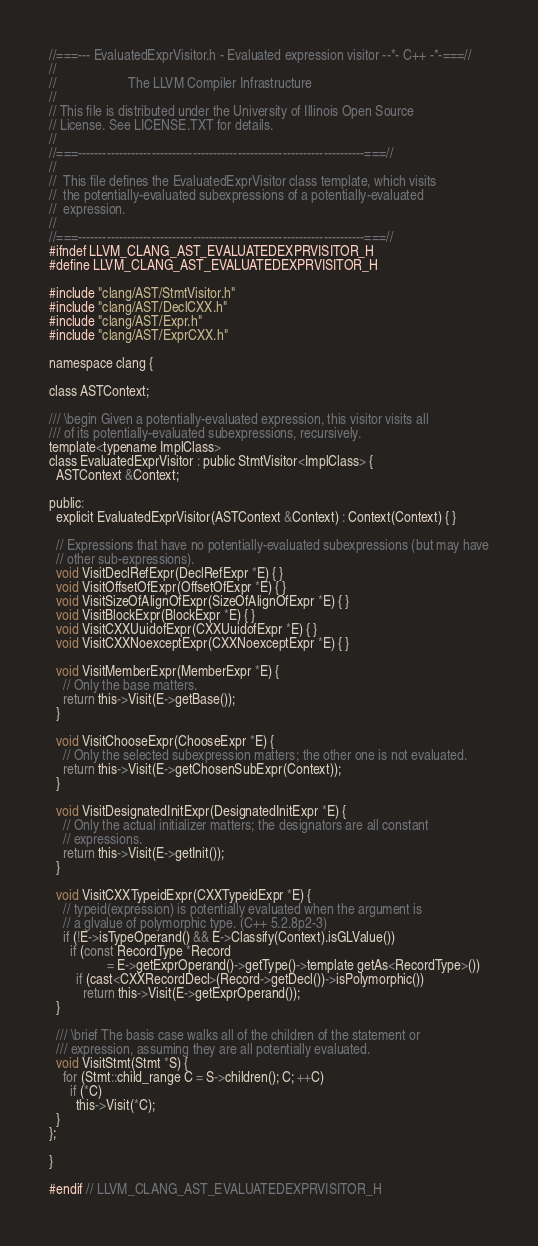Convert code to text. <code><loc_0><loc_0><loc_500><loc_500><_C_>//===--- EvaluatedExprVisitor.h - Evaluated expression visitor --*- C++ -*-===//
//
//                     The LLVM Compiler Infrastructure
//
// This file is distributed under the University of Illinois Open Source
// License. See LICENSE.TXT for details.
//
//===----------------------------------------------------------------------===//
//
//  This file defines the EvaluatedExprVisitor class template, which visits
//  the potentially-evaluated subexpressions of a potentially-evaluated
//  expression.
//
//===----------------------------------------------------------------------===//
#ifndef LLVM_CLANG_AST_EVALUATEDEXPRVISITOR_H
#define LLVM_CLANG_AST_EVALUATEDEXPRVISITOR_H

#include "clang/AST/StmtVisitor.h"
#include "clang/AST/DeclCXX.h"
#include "clang/AST/Expr.h"
#include "clang/AST/ExprCXX.h"

namespace clang {
  
class ASTContext;
  
/// \begin Given a potentially-evaluated expression, this visitor visits all
/// of its potentially-evaluated subexpressions, recursively.
template<typename ImplClass>
class EvaluatedExprVisitor : public StmtVisitor<ImplClass> {
  ASTContext &Context;
  
public:
  explicit EvaluatedExprVisitor(ASTContext &Context) : Context(Context) { }
  
  // Expressions that have no potentially-evaluated subexpressions (but may have
  // other sub-expressions).
  void VisitDeclRefExpr(DeclRefExpr *E) { }
  void VisitOffsetOfExpr(OffsetOfExpr *E) { }
  void VisitSizeOfAlignOfExpr(SizeOfAlignOfExpr *E) { }
  void VisitBlockExpr(BlockExpr *E) { }
  void VisitCXXUuidofExpr(CXXUuidofExpr *E) { }  
  void VisitCXXNoexceptExpr(CXXNoexceptExpr *E) { }
  
  void VisitMemberExpr(MemberExpr *E) {
    // Only the base matters.
    return this->Visit(E->getBase());
  }
  
  void VisitChooseExpr(ChooseExpr *E) {
    // Only the selected subexpression matters; the other one is not evaluated.
    return this->Visit(E->getChosenSubExpr(Context));
  }
                 
  void VisitDesignatedInitExpr(DesignatedInitExpr *E) {
    // Only the actual initializer matters; the designators are all constant
    // expressions.
    return this->Visit(E->getInit());
  }
  
  void VisitCXXTypeidExpr(CXXTypeidExpr *E) {
    // typeid(expression) is potentially evaluated when the argument is
    // a glvalue of polymorphic type. (C++ 5.2.8p2-3)
    if (!E->isTypeOperand() && E->Classify(Context).isGLValue())
      if (const RecordType *Record 
                 = E->getExprOperand()->getType()->template getAs<RecordType>())
        if (cast<CXXRecordDecl>(Record->getDecl())->isPolymorphic())
          return this->Visit(E->getExprOperand());
  }
  
  /// \brief The basis case walks all of the children of the statement or
  /// expression, assuming they are all potentially evaluated.
  void VisitStmt(Stmt *S) {
    for (Stmt::child_range C = S->children(); C; ++C)
      if (*C)
        this->Visit(*C);
  }
};

}

#endif // LLVM_CLANG_AST_EVALUATEDEXPRVISITOR_H
</code> 